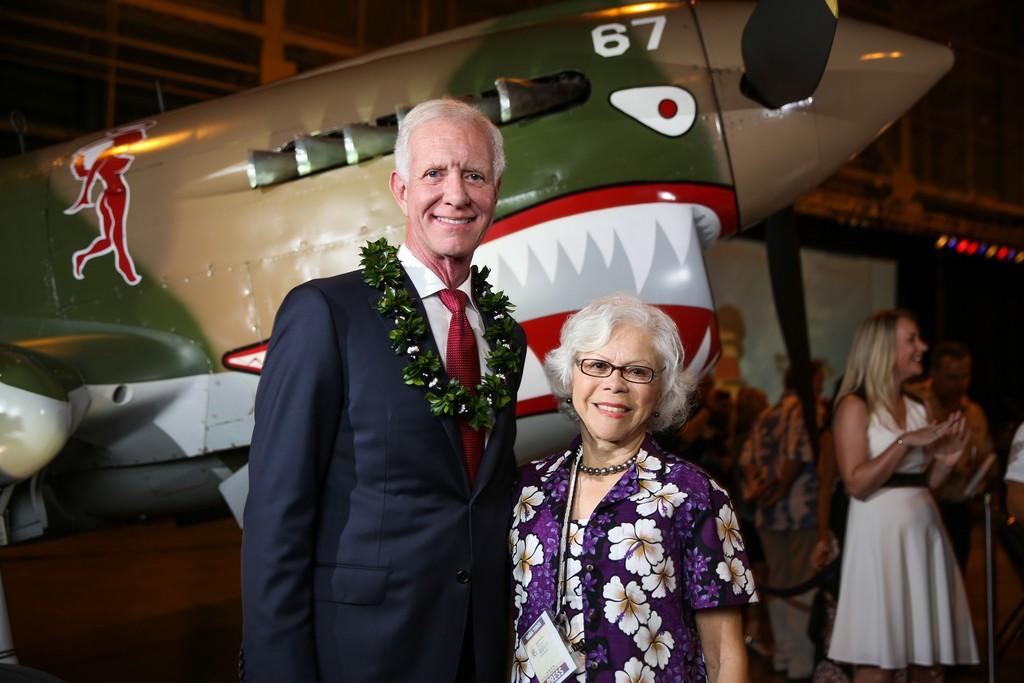<image>
Share a concise interpretation of the image provided. a couple standing in front of an item with 67 on it 